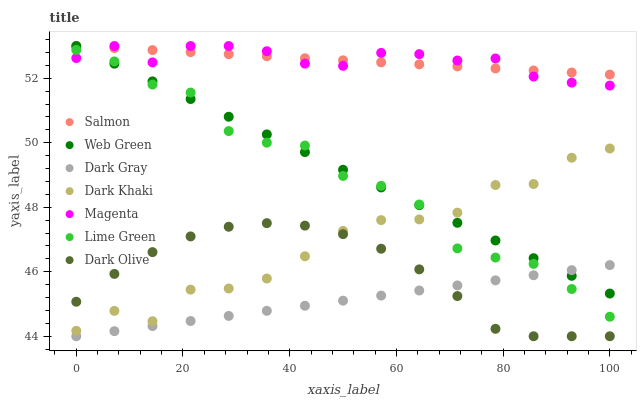Does Dark Gray have the minimum area under the curve?
Answer yes or no. Yes. Does Magenta have the maximum area under the curve?
Answer yes or no. Yes. Does Dark Olive have the minimum area under the curve?
Answer yes or no. No. Does Dark Olive have the maximum area under the curve?
Answer yes or no. No. Is Salmon the smoothest?
Answer yes or no. Yes. Is Dark Khaki the roughest?
Answer yes or no. Yes. Is Dark Olive the smoothest?
Answer yes or no. No. Is Dark Olive the roughest?
Answer yes or no. No. Does Dark Olive have the lowest value?
Answer yes or no. Yes. Does Salmon have the lowest value?
Answer yes or no. No. Does Magenta have the highest value?
Answer yes or no. Yes. Does Dark Olive have the highest value?
Answer yes or no. No. Is Dark Olive less than Magenta?
Answer yes or no. Yes. Is Salmon greater than Dark Gray?
Answer yes or no. Yes. Does Dark Gray intersect Lime Green?
Answer yes or no. Yes. Is Dark Gray less than Lime Green?
Answer yes or no. No. Is Dark Gray greater than Lime Green?
Answer yes or no. No. Does Dark Olive intersect Magenta?
Answer yes or no. No. 